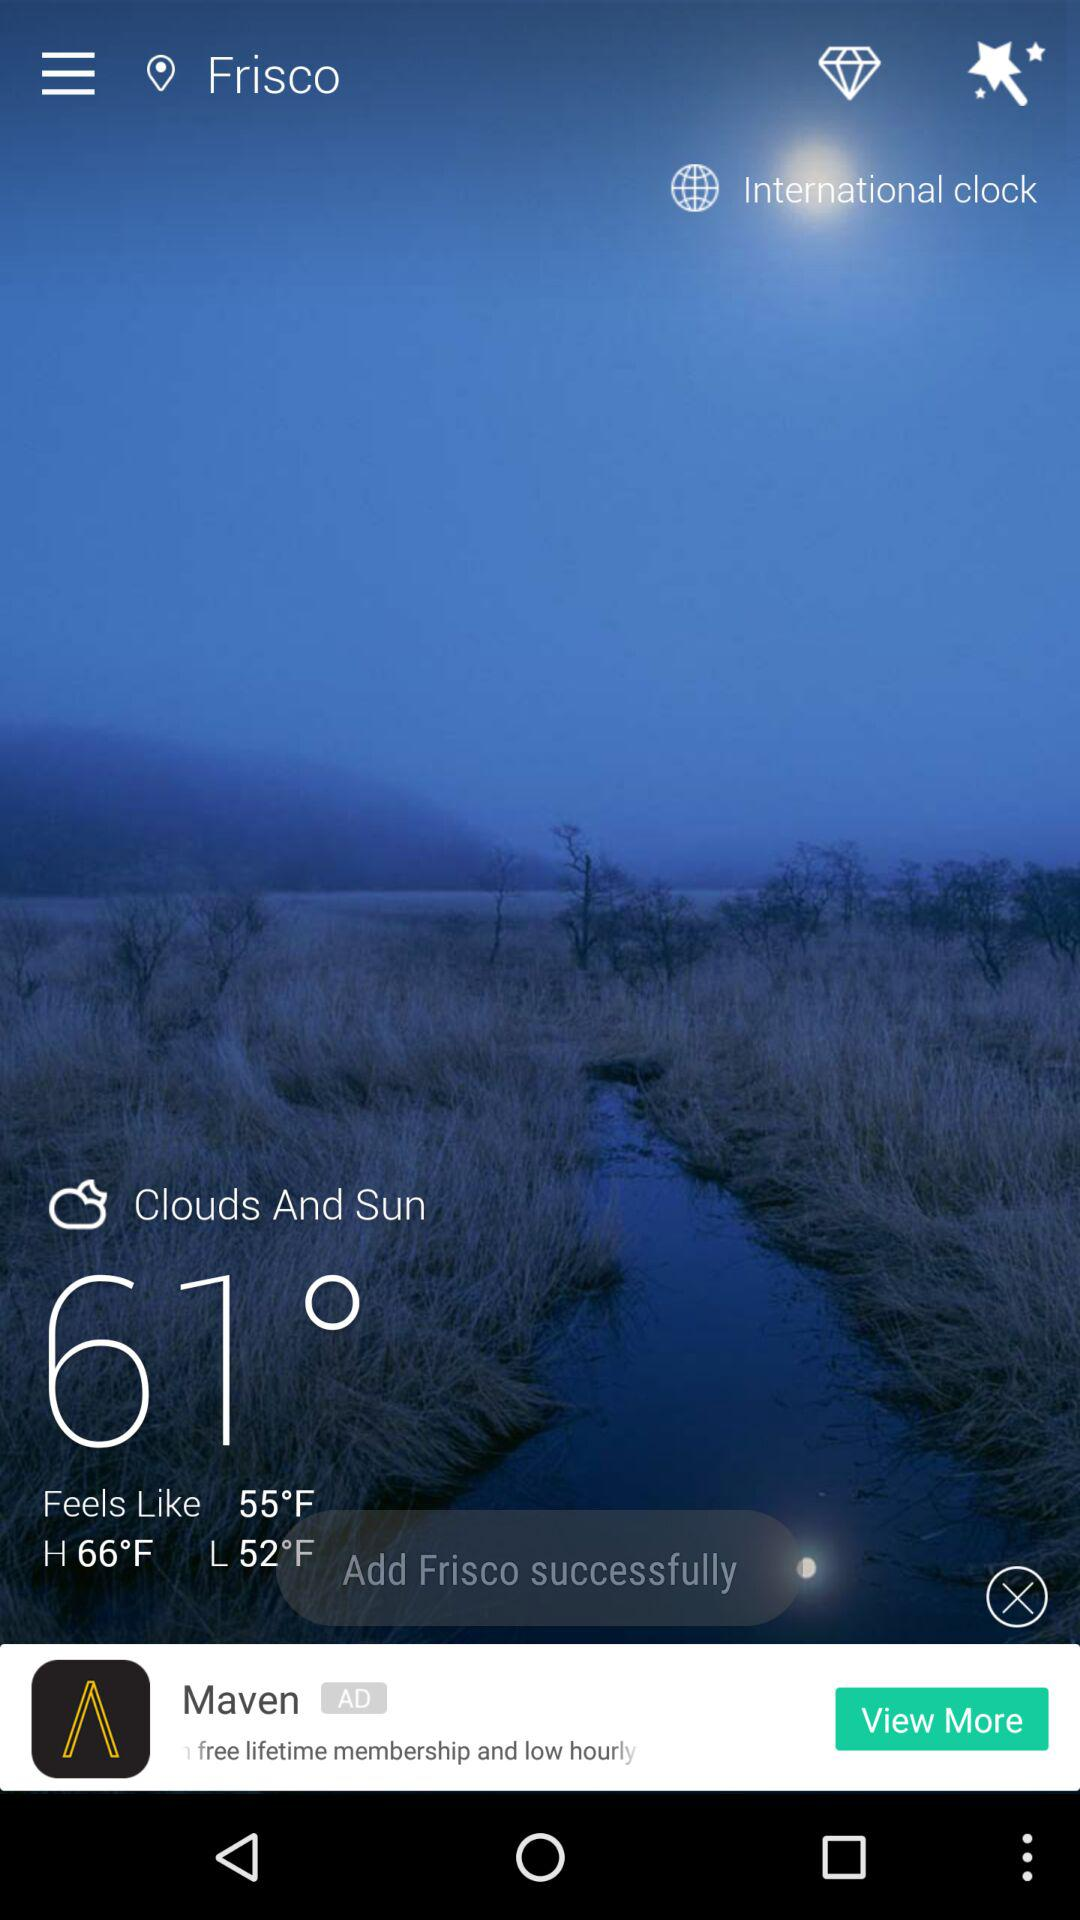What is the temperature? The temperature is 61°. 